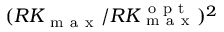Convert formula to latex. <formula><loc_0><loc_0><loc_500><loc_500>( R K _ { m a x } / R K _ { m a x } ^ { o p t } ) ^ { 2 }</formula> 